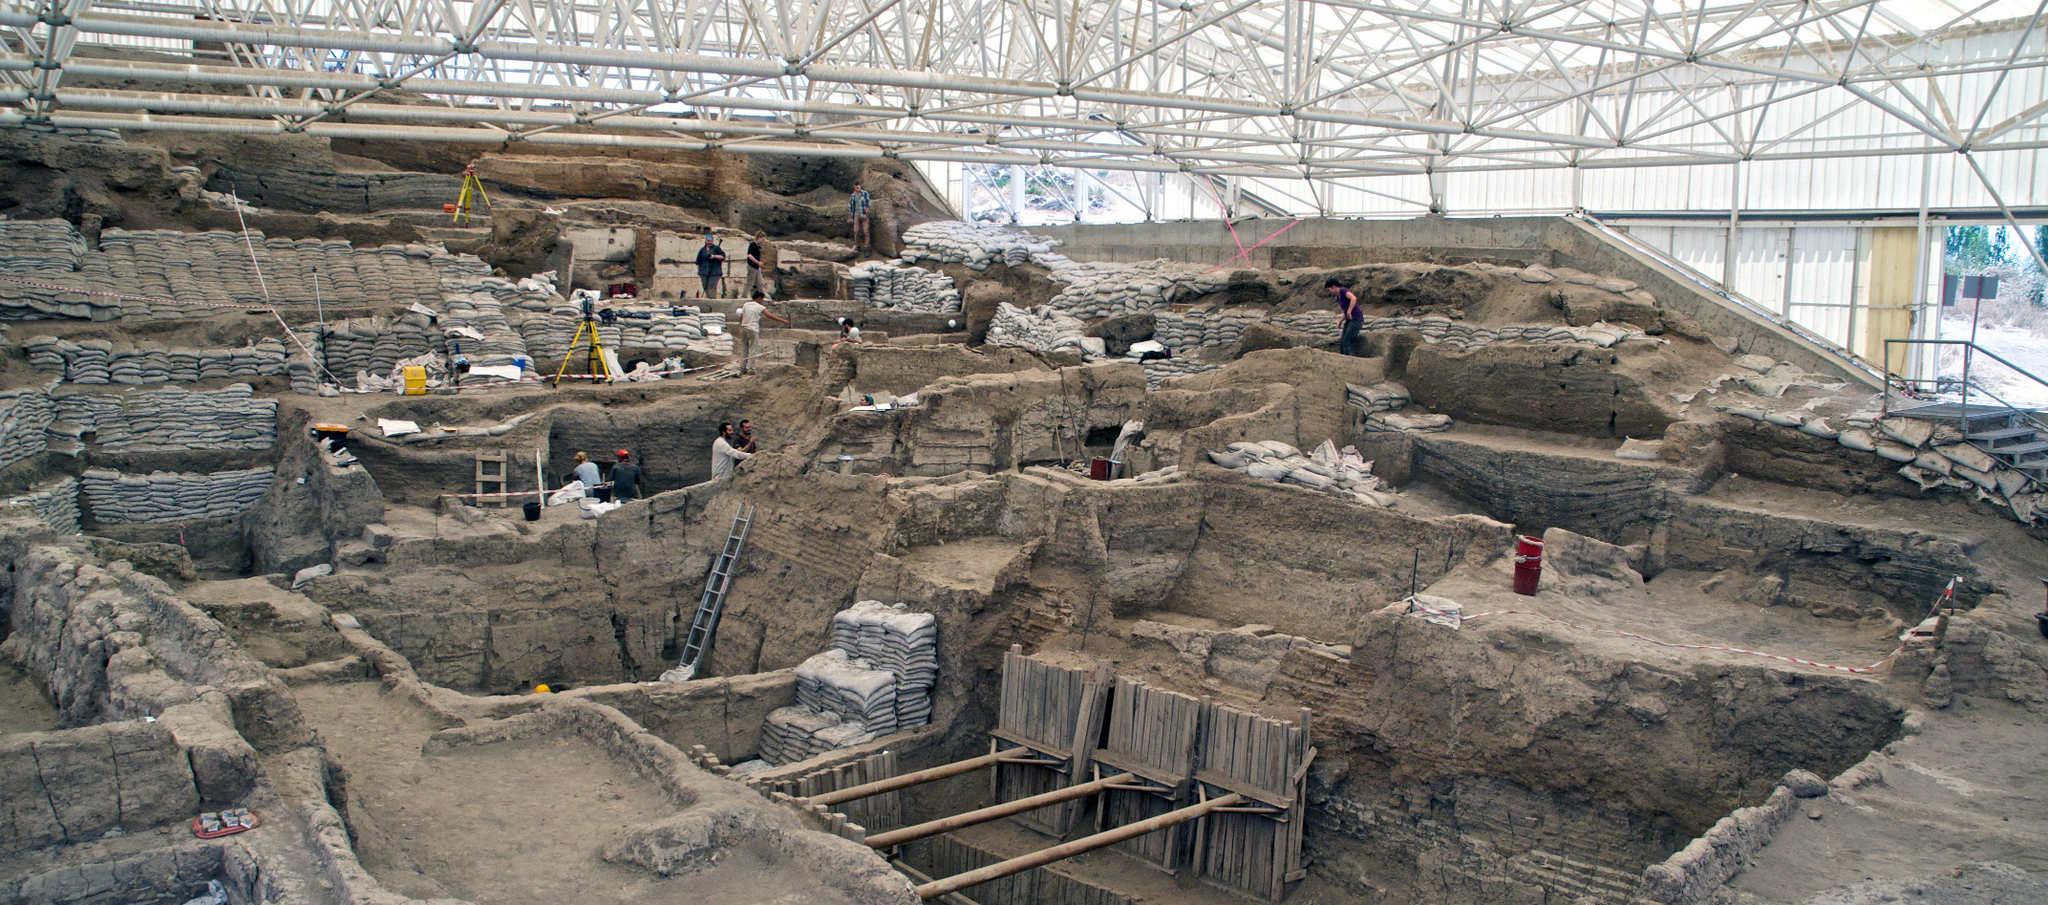Write a detailed description of the given image. The image features the archaeological site of Çatalhöyük in Turkey, widely recognized as one of the earliest human settlements in history. Taken from an elevated perspective, the photograph offers an expansive view of the archaeological dig in progress. A significant portion of the site is sheltered under an expansive white roof, providing protection to the delicate ruins and the archaeologists working meticulously on their explorations.

Underneath the roof, the intricate remnants of the ancient settlement are clearly visible. These ruins showcase complex architecture, evident from the multiple layers of walls and structural elements. Wooden scaffolding is strategically placed in certain areas to facilitate the careful excavation process. The scene is punctuated with workers in different locations, identifiable by their vibrant clothing and tools. Colorful elements like yellow and red from their attire and equipment contrast vividly with the brown and gray earthy tones of the ruins. Overall, the image offers an intriguing look into the painstaking process of uncovering historical remains at Çatalhöyük, highlighting both the scale and the detailed work involved in such archaeological endeavors. 